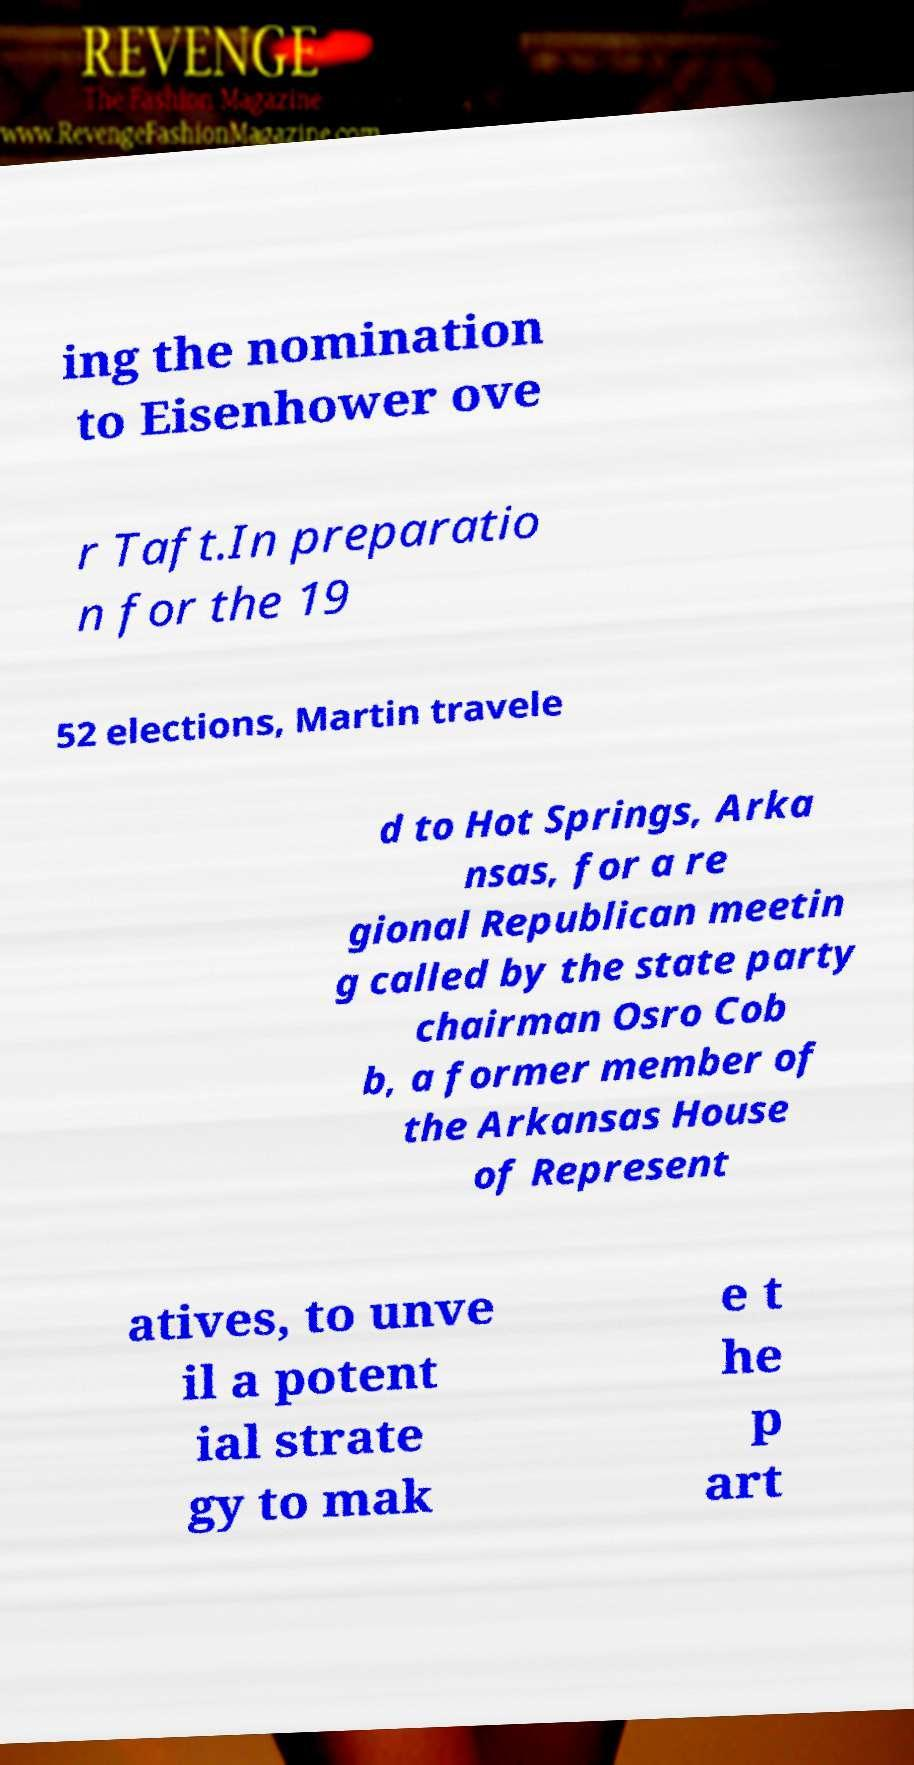Could you extract and type out the text from this image? ing the nomination to Eisenhower ove r Taft.In preparatio n for the 19 52 elections, Martin travele d to Hot Springs, Arka nsas, for a re gional Republican meetin g called by the state party chairman Osro Cob b, a former member of the Arkansas House of Represent atives, to unve il a potent ial strate gy to mak e t he p art 